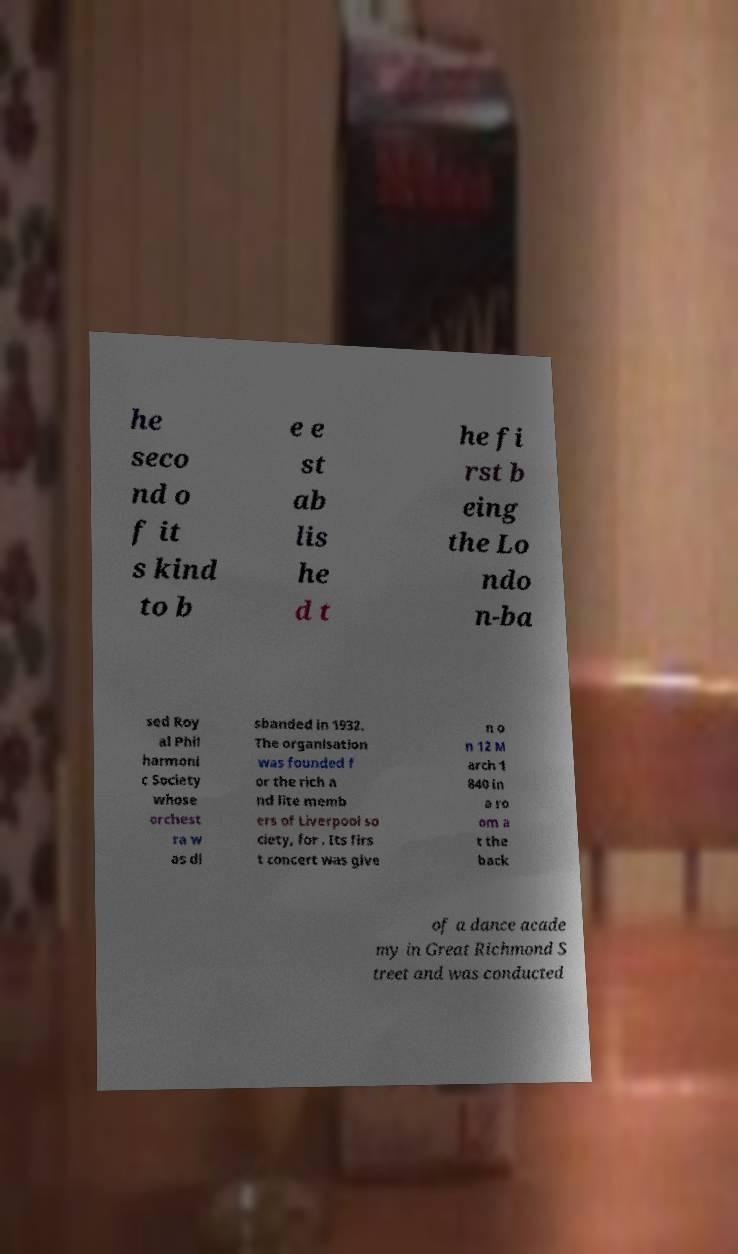I need the written content from this picture converted into text. Can you do that? he seco nd o f it s kind to b e e st ab lis he d t he fi rst b eing the Lo ndo n-ba sed Roy al Phil harmoni c Society whose orchest ra w as di sbanded in 1932. The organisation was founded f or the rich a nd lite memb ers of Liverpool so ciety, for . Its firs t concert was give n o n 12 M arch 1 840 in a ro om a t the back of a dance acade my in Great Richmond S treet and was conducted 